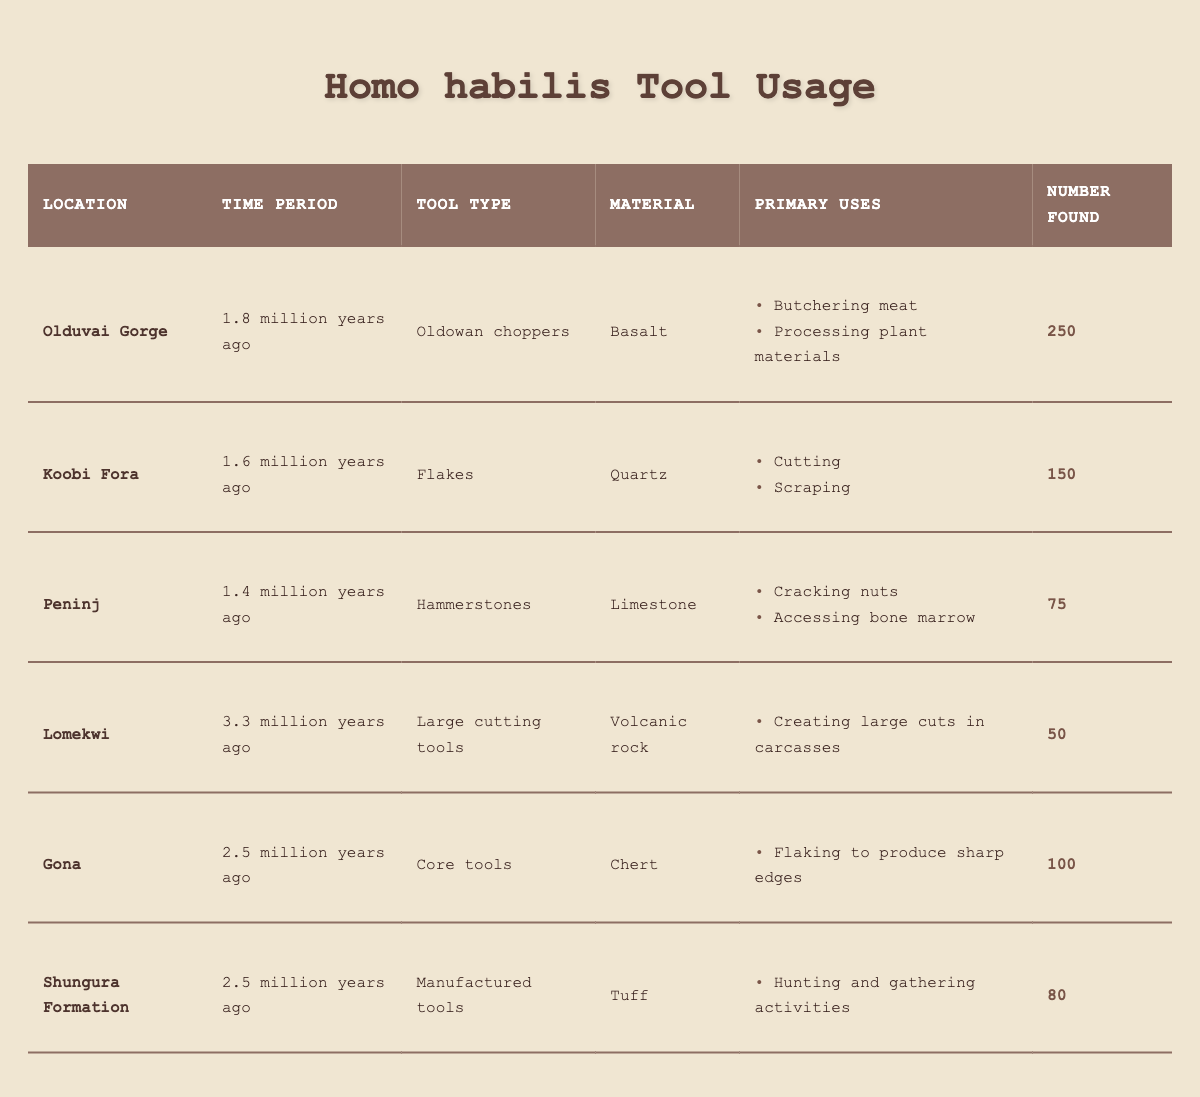What tool type was found in the highest quantity? By examining the “Number Found” column in the table, Oldowan choppers from Olduvai Gorge has the highest count with 250 tools.
Answer: Oldowan choppers Which location contained tools made from limestone? In the “Material” column, Peninj is associated with hammerstones, which are made from limestone.
Answer: Peninj How many tools were found at Gona? The table lists the number found at Gona as 100.
Answer: 100 Which materials were used for tools that primarily processed food? From the “Primary Uses” column for Oldowan choppers, basalt was used for butchering meat and processing plant materials, and limestone was used for cracking nuts and accessing bone marrow.
Answer: Basalt and limestone What is the total number of tools found at all locations? Adding the number found from each location: 250 (Olduvai Gorge) + 150 (Koobi Fora) + 75 (Peninj) + 50 (Lomekwi) + 100 (Gona) + 80 (Shungura Formation) equals 705.
Answer: 705 Is there any evidence of tool use 3.3 million years ago? The table indicates that large cutting tools from Lomekwi, dated at 3.3 million years ago, were indeed used.
Answer: Yes What percentage of the total tools found comes from Olduvai Gorge? From the total tools found (705), the number found at Olduvai Gorge is 250. The percentage calculation is (250 / 705) * 100 ≈ 35.4%.
Answer: 35.4% Which time period has the oldest tools identified in this data? In the “Time Period” column, Lomekwi, with tools from 3.3 million years ago, is the oldest.
Answer: 3.3 million years ago Which tool type was specifically used for hunting and gathering activities? According to the “Primary Uses” column, manufactured tools from the Shungura Formation were used for hunting and gathering activities.
Answer: Manufactured tools If one were to categorize the tools by their primary use for processing plant materials, which locations would be relevant? Olduvai Gorge is for butchering meat and processing plant materials, while Peninj is for processing nuts and accessing bone marrow; thus, both locations are relevant.
Answer: Olduvai Gorge and Peninj 